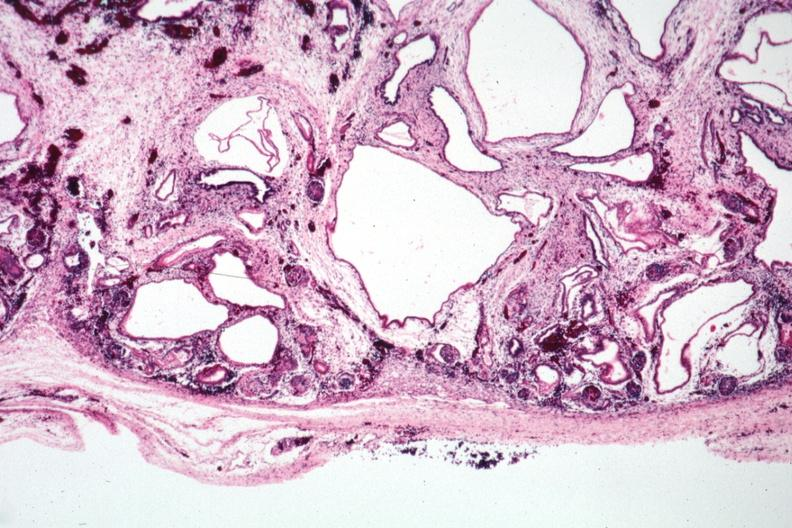where is this?
Answer the question using a single word or phrase. Urinary 